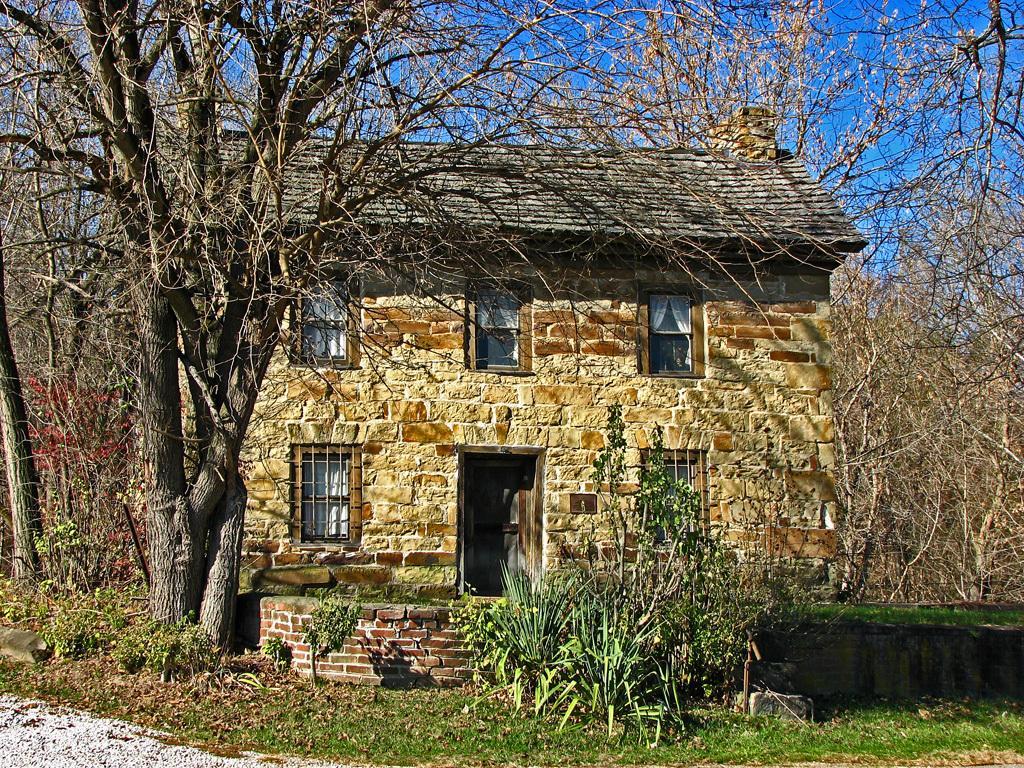In one or two sentences, can you explain what this image depicts? In this picture I can see a house, there is grass, there are plants, trees, and in the background there is sky. 